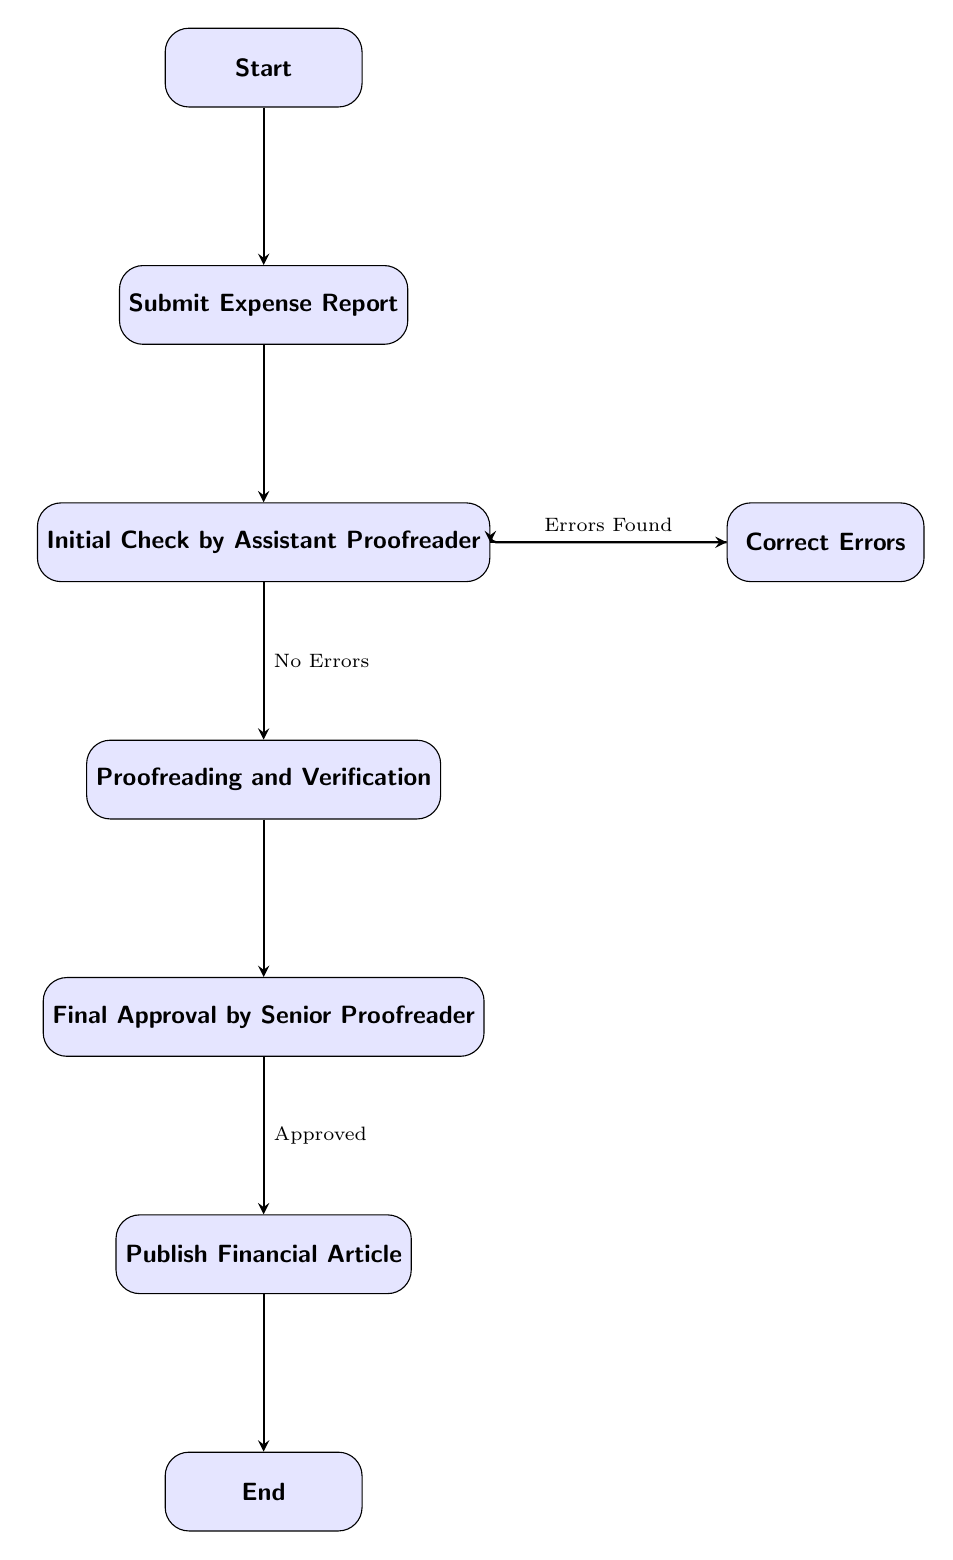What is the first step in the process? The first node in the flow chart is labeled "Start," indicating that this is the beginning of the expense review and approval process. Thus, the first step is to initiate the process.
Answer: Start How many nodes are present in the diagram? By counting each labeled box in the flow chart, we find there are a total of seven distinct nodes, each representing a step in the process.
Answer: 7 What happens after the "Submit Expense Report"? The edge from "Submit Expense Report" leads directly to the next node, which is "Initial Check by Assistant Proofreader," signifying that after submission, an initial review is performed.
Answer: Initial Check by Assistant Proofreader What action occurs if "Errors Found"? If errors are found during the "Initial Check," the process flows to the "Correct Errors" node, indicating that correction of errors is necessary before proceeding.
Answer: Correct Errors What is the final step before the process ends? The penultimate action before reaching the end point is "Publish Financial Article," which is the last active step before concluding the process.
Answer: Publish Financial Article What is the relationship between "Initial Check" and "Proofread"? If "No Errors" are found during the "Initial Check," the flow chart indicates a transition from "Initial Check" to "Proofread," indicating a successful review that allows for the proofreading step to commence.
Answer: No Errors How many edges connect the nodes in this diagram? By examining the connections or "edges" that link the nodes, we can determine that there are a total of eight directed edges in the flow chart.
Answer: 8 